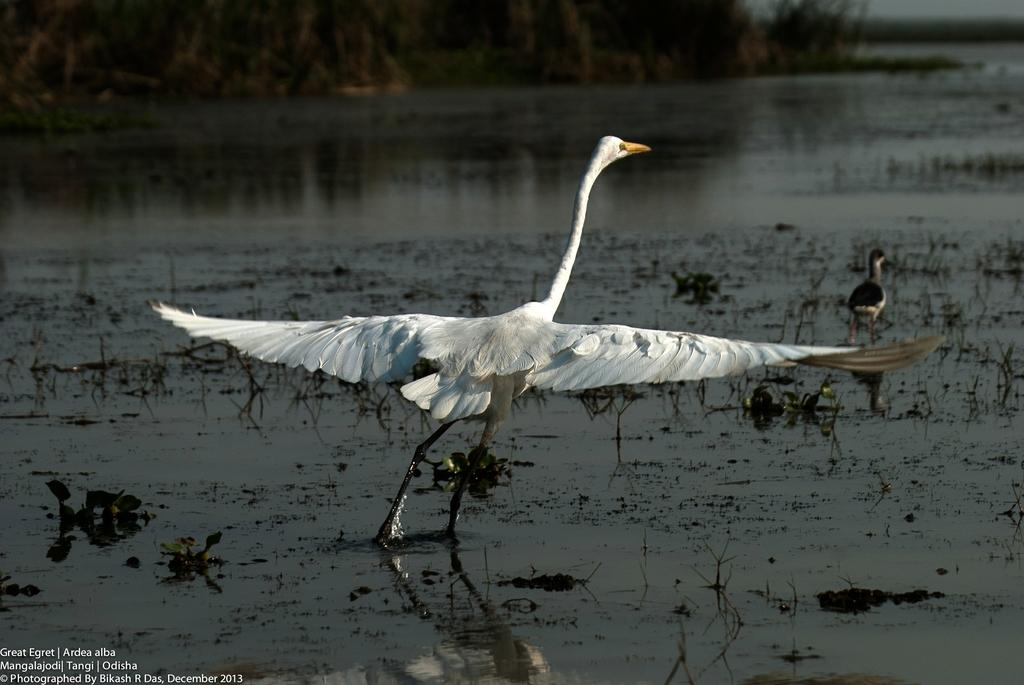What type of animals can be seen in the water in the image? There are birds in the water in the image. What type of vegetation is present in the image? There are trees in the image. What type of geographical feature can be seen in the image? There are mountains in the image. What is written at the bottom of the image? There is text at the bottom of the image. What part of the natural environment is visible in the image? The sky is visible in the image. How many children are playing with the wounded giant in the image? There are no children or giants present in the image; it features birds in the water, trees, mountains, text, and the sky. 